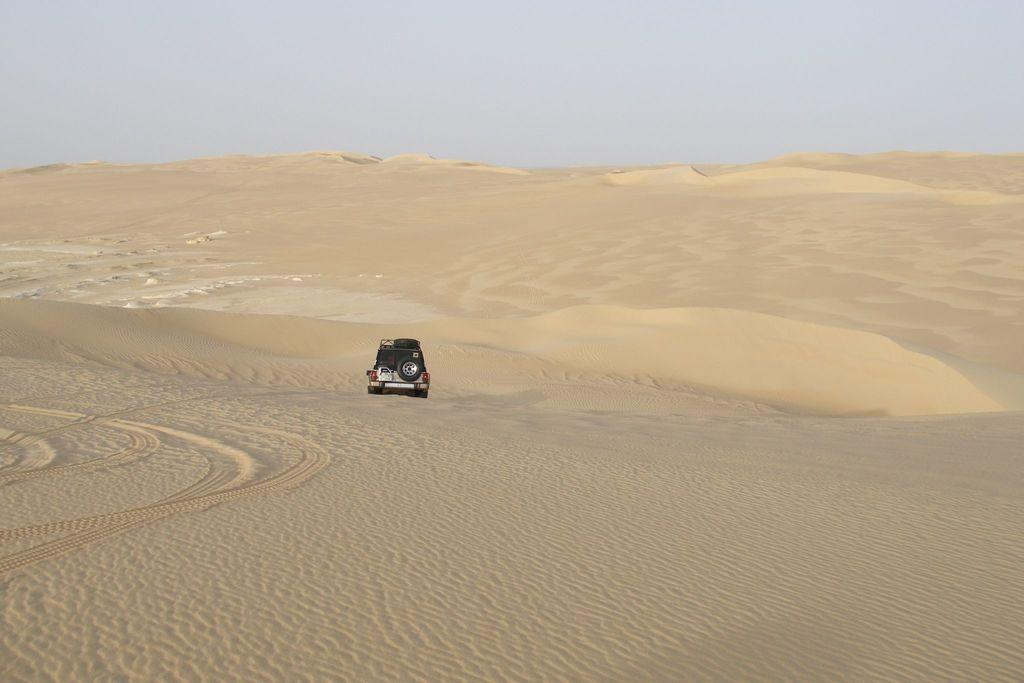What is the main subject in the center of the image? There is a jeep in the center of the image. What is the terrain on which the jeep is situated? The jeep is on the singing sand. What can be seen in the background of the image? The sky is visible in the image. How would you describe the weather based on the appearance of the sky? The sky appears cloudy, which might suggest overcast or potentially rainy weather. How many seeds can be seen growing on the slope in the image? There are no seeds or slopes present in the image; it features a jeep on the singing sand with a cloudy sky in the background. 